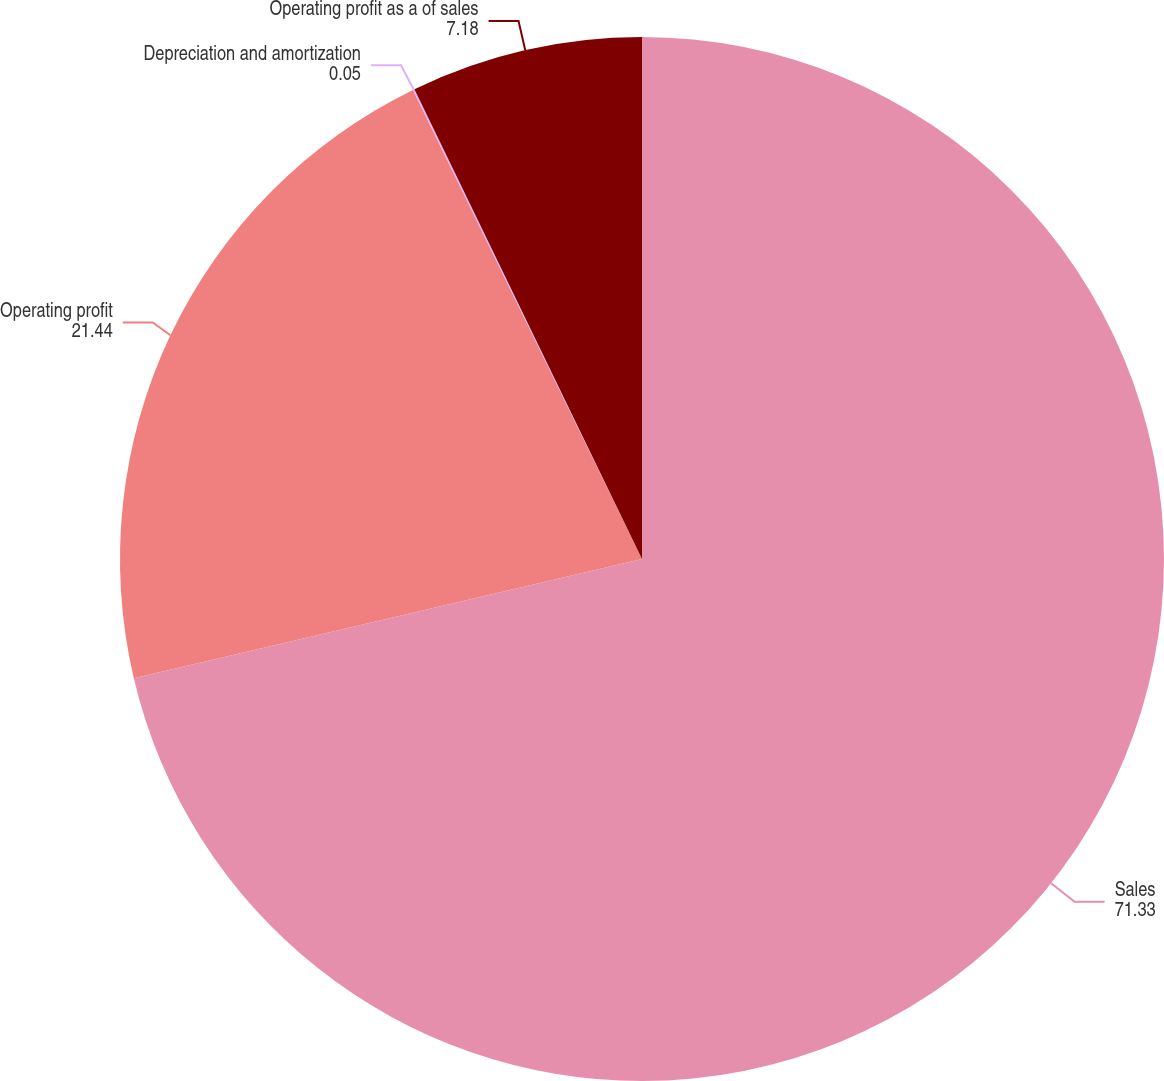Convert chart. <chart><loc_0><loc_0><loc_500><loc_500><pie_chart><fcel>Sales<fcel>Operating profit<fcel>Depreciation and amortization<fcel>Operating profit as a of sales<nl><fcel>71.33%<fcel>21.44%<fcel>0.05%<fcel>7.18%<nl></chart> 